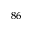Convert formula to latex. <formula><loc_0><loc_0><loc_500><loc_500>^ { 8 6 }</formula> 